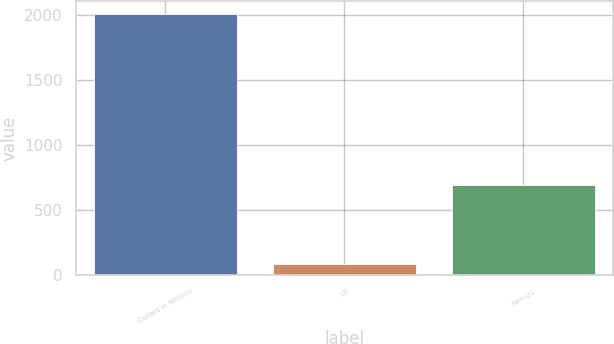<chart> <loc_0><loc_0><loc_500><loc_500><bar_chart><fcel>Dollars in Millions<fcel>US<fcel>Non-US<nl><fcel>2006<fcel>82<fcel>693<nl></chart> 